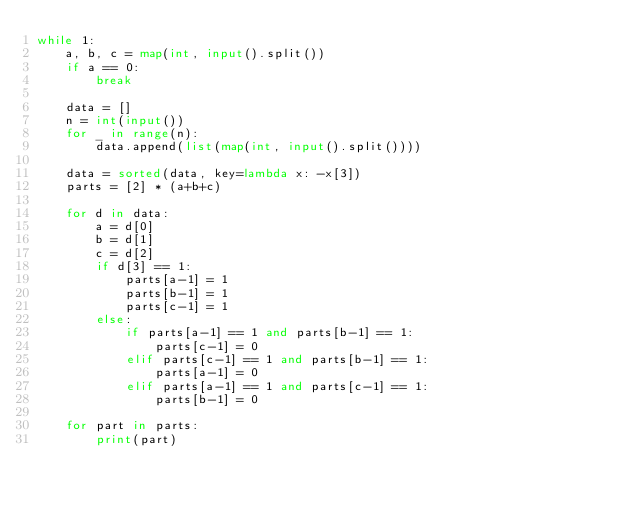Convert code to text. <code><loc_0><loc_0><loc_500><loc_500><_Python_>while 1:
    a, b, c = map(int, input().split())
    if a == 0:
        break

    data = []
    n = int(input())
    for _ in range(n):
        data.append(list(map(int, input().split())))

    data = sorted(data, key=lambda x: -x[3])
    parts = [2] * (a+b+c)

    for d in data:
        a = d[0]
        b = d[1]
        c = d[2]
        if d[3] == 1:
            parts[a-1] = 1
            parts[b-1] = 1
            parts[c-1] = 1
        else:
            if parts[a-1] == 1 and parts[b-1] == 1:
                parts[c-1] = 0
            elif parts[c-1] == 1 and parts[b-1] == 1:
                parts[a-1] = 0
            elif parts[a-1] == 1 and parts[c-1] == 1:
                parts[b-1] = 0

    for part in parts:
        print(part)
</code> 